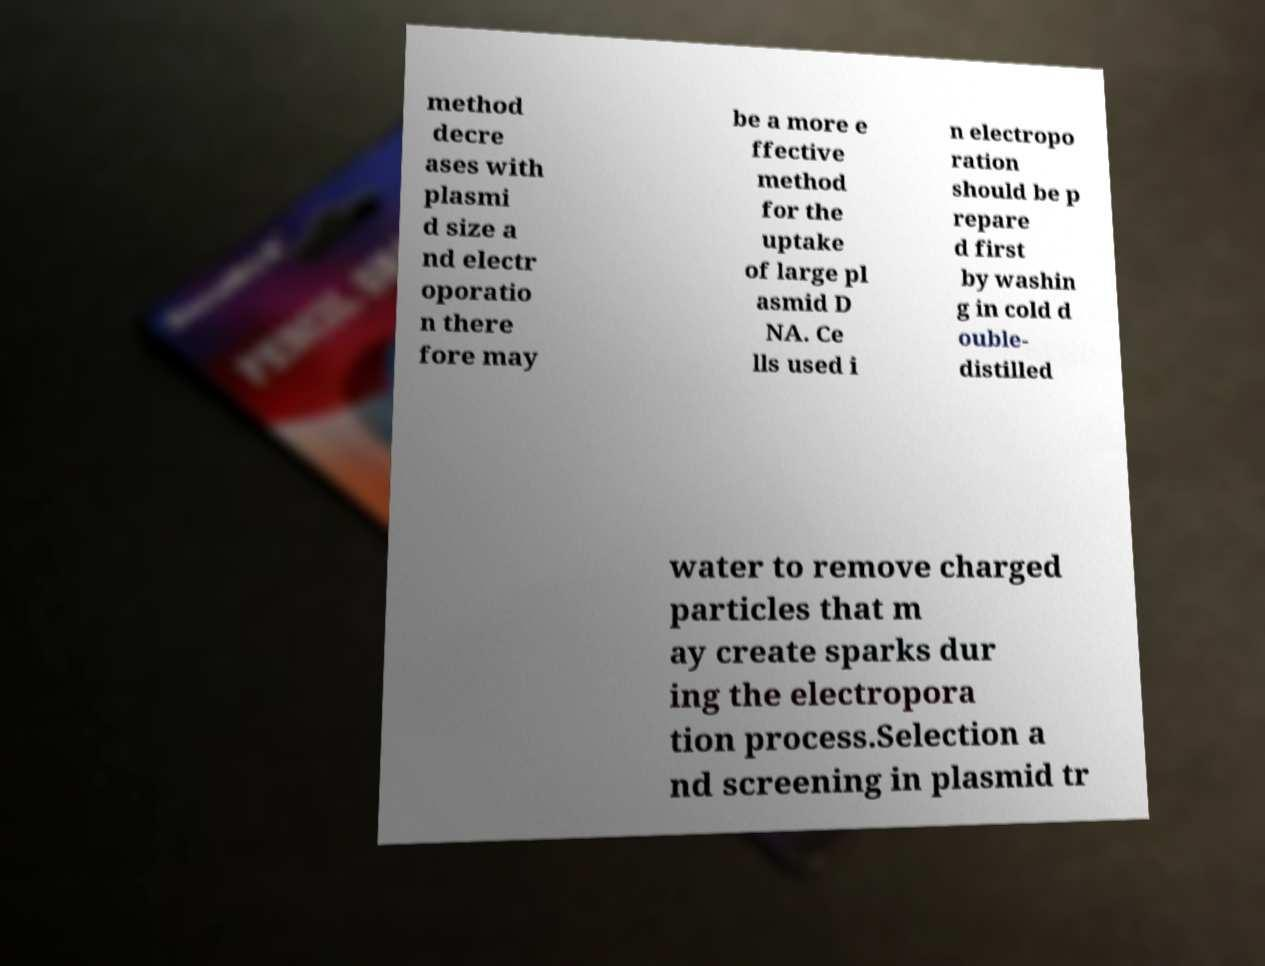Please read and relay the text visible in this image. What does it say? method decre ases with plasmi d size a nd electr oporatio n there fore may be a more e ffective method for the uptake of large pl asmid D NA. Ce lls used i n electropo ration should be p repare d first by washin g in cold d ouble- distilled water to remove charged particles that m ay create sparks dur ing the electropora tion process.Selection a nd screening in plasmid tr 